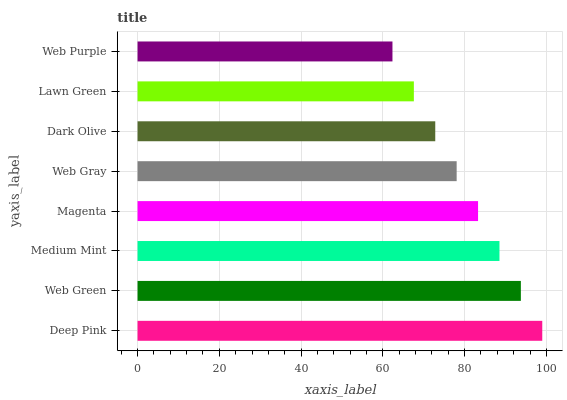Is Web Purple the minimum?
Answer yes or no. Yes. Is Deep Pink the maximum?
Answer yes or no. Yes. Is Web Green the minimum?
Answer yes or no. No. Is Web Green the maximum?
Answer yes or no. No. Is Deep Pink greater than Web Green?
Answer yes or no. Yes. Is Web Green less than Deep Pink?
Answer yes or no. Yes. Is Web Green greater than Deep Pink?
Answer yes or no. No. Is Deep Pink less than Web Green?
Answer yes or no. No. Is Magenta the high median?
Answer yes or no. Yes. Is Web Gray the low median?
Answer yes or no. Yes. Is Web Green the high median?
Answer yes or no. No. Is Medium Mint the low median?
Answer yes or no. No. 